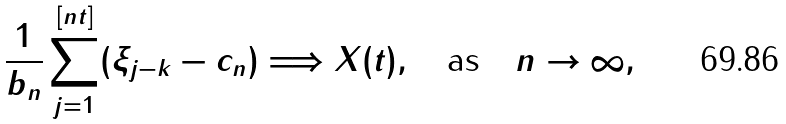Convert formula to latex. <formula><loc_0><loc_0><loc_500><loc_500>\frac { 1 } { b _ { n } } \sum _ { j = 1 } ^ { [ n t ] } ( \xi _ { j - k } - c _ { n } ) \Longrightarrow X ( t ) , \quad \text {as} \quad n \to \infty ,</formula> 